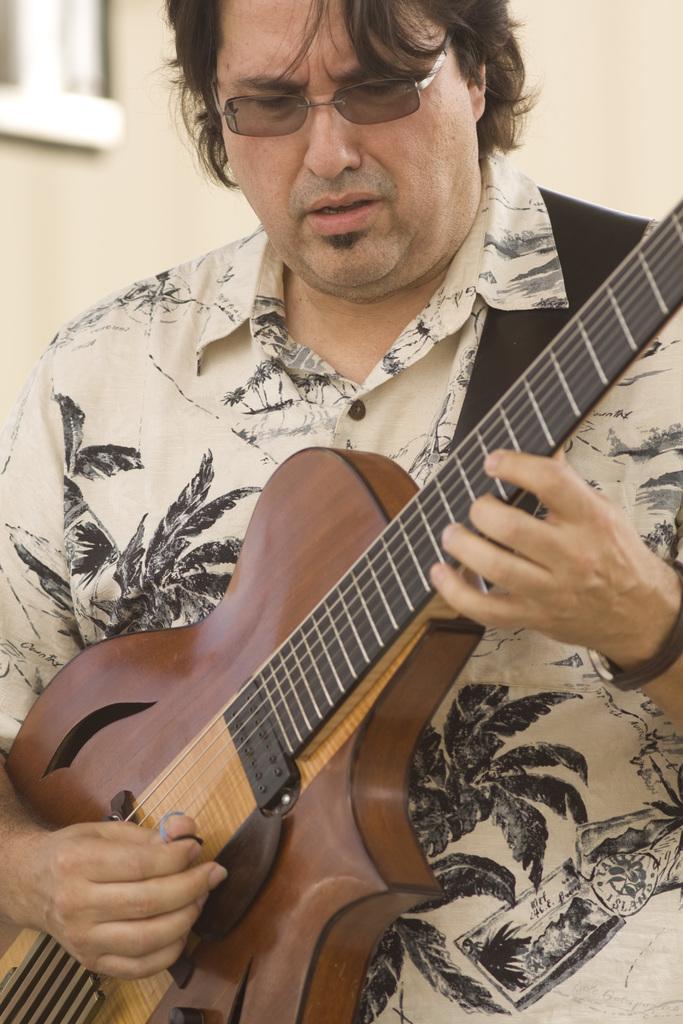Please provide a concise description of this image. In this picture there is a man holding a guitar. He is wearing a printed shirt and spectacles. In the background there is a wall. 